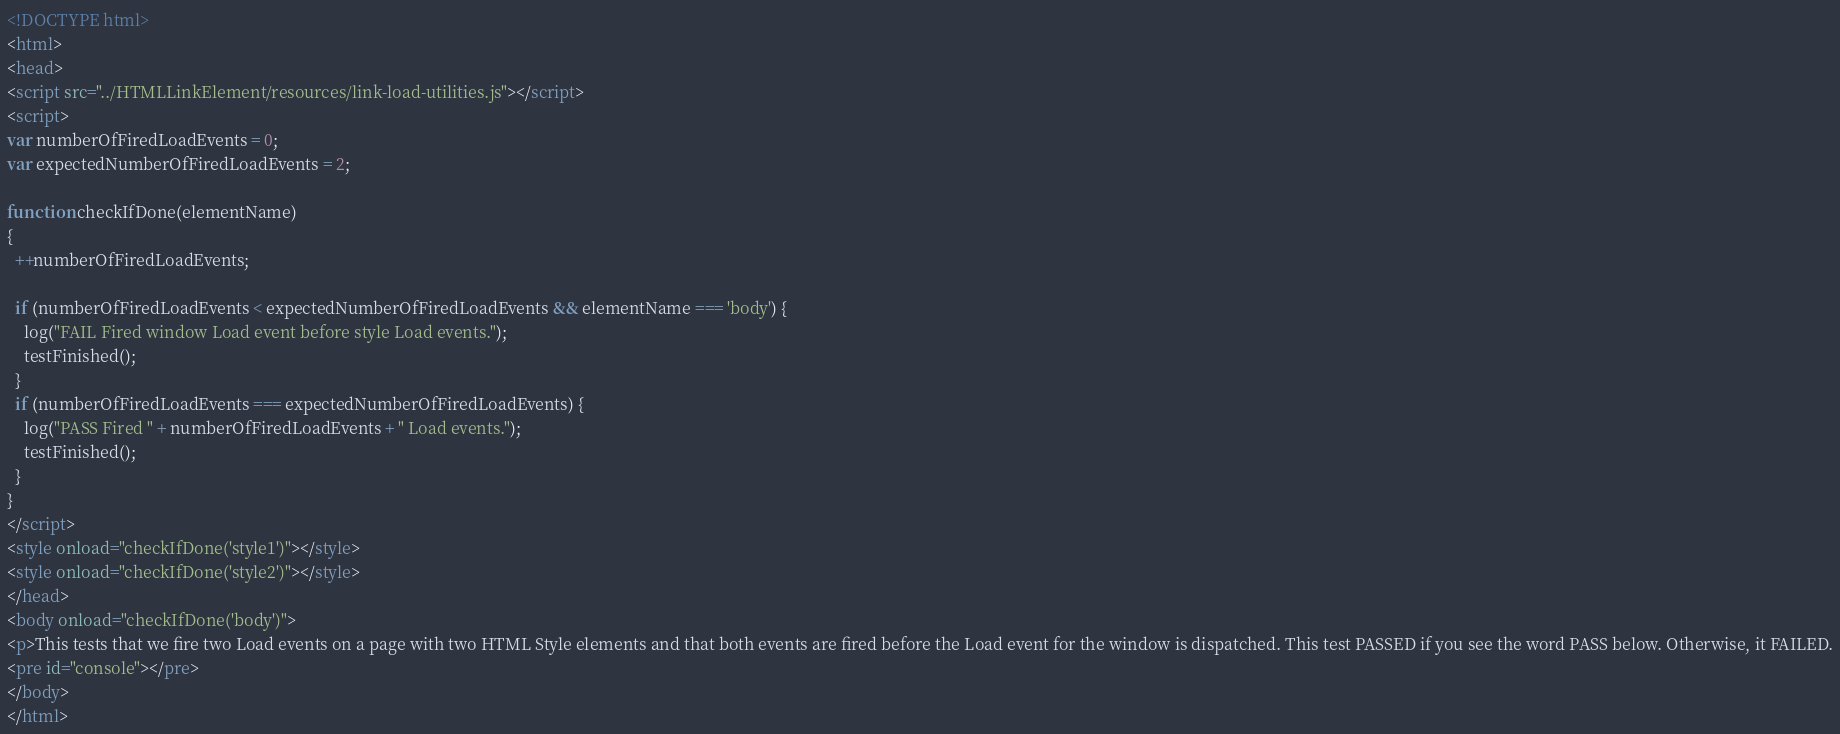Convert code to text. <code><loc_0><loc_0><loc_500><loc_500><_HTML_><!DOCTYPE html>
<html>
<head>
<script src="../HTMLLinkElement/resources/link-load-utilities.js"></script>
<script>
var numberOfFiredLoadEvents = 0;
var expectedNumberOfFiredLoadEvents = 2;

function checkIfDone(elementName)
{
  ++numberOfFiredLoadEvents;

  if (numberOfFiredLoadEvents < expectedNumberOfFiredLoadEvents && elementName === 'body') {
    log("FAIL Fired window Load event before style Load events.");
    testFinished();
  }
  if (numberOfFiredLoadEvents === expectedNumberOfFiredLoadEvents) {
    log("PASS Fired " + numberOfFiredLoadEvents + " Load events.");
    testFinished();
  }
}
</script>
<style onload="checkIfDone('style1')"></style>
<style onload="checkIfDone('style2')"></style>
</head>
<body onload="checkIfDone('body')">
<p>This tests that we fire two Load events on a page with two HTML Style elements and that both events are fired before the Load event for the window is dispatched. This test PASSED if you see the word PASS below. Otherwise, it FAILED.
<pre id="console"></pre>
</body>
</html>
</code> 